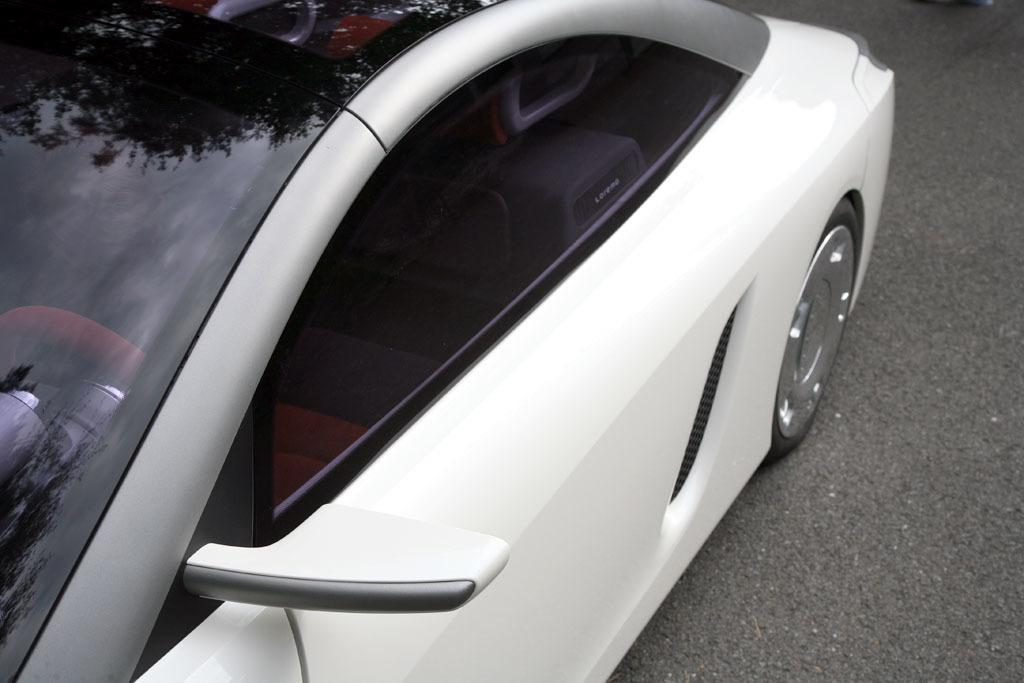What color is the car in the image? The car in the image is white. Where is the car located in the image? The car is on a road. Can you see a pig playing with a bead near the car in the image? No, there is no pig or bead present in the image. 